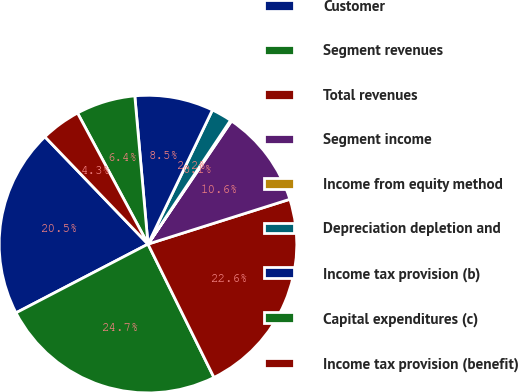<chart> <loc_0><loc_0><loc_500><loc_500><pie_chart><fcel>Customer<fcel>Segment revenues<fcel>Total revenues<fcel>Segment income<fcel>Income from equity method<fcel>Depreciation depletion and<fcel>Income tax provision (b)<fcel>Capital expenditures (c)<fcel>Income tax provision (benefit)<nl><fcel>20.46%<fcel>24.67%<fcel>22.56%<fcel>10.64%<fcel>0.13%<fcel>2.23%<fcel>8.54%<fcel>6.44%<fcel>4.33%<nl></chart> 